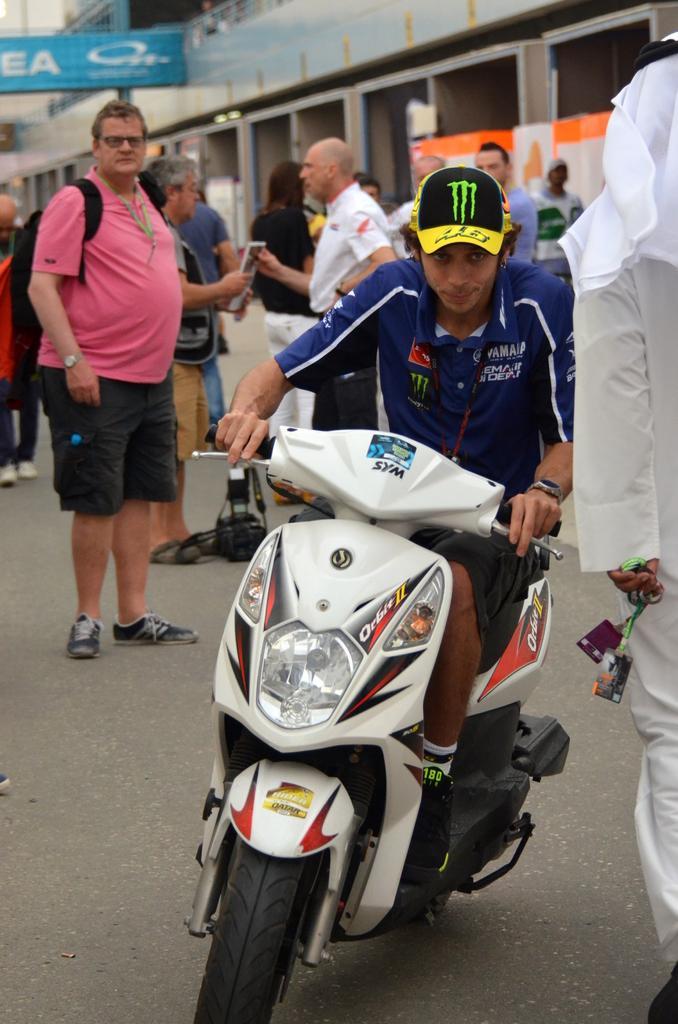Describe this image in one or two sentences. This picture is clicked outside the city. In front of the picture, we see a man in blue t-shirt wearing yellow cap is riding bike. Behind him, we see many people standing on road. The man on the left corner of the picture is wearing pink t-shirt and black backpack. Behind him, we see a building and on top of it, we see a board in blue color. 